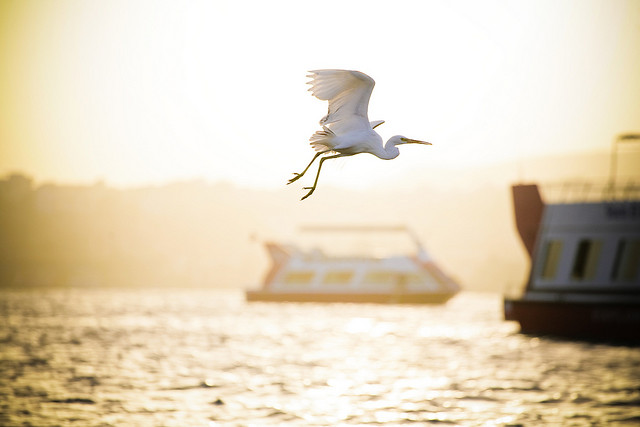What do you think the people on the boat might be experiencing? The people on the boat might be experiencing a peaceful and relaxing journey, enjoying the gentle waves and the beautiful scenery with the setting sun casting a warm glow over the water. Can you give a detailed account of what might happen next in the image? As the bird continues its flight, it will likely search for a place to land, perhaps on the quay or another spot along the waterway. Simultaneously, the boats might be coming to anchor for the evening, with their passengers preparing to disembark and enjoy the surroundings, perhaps taking a stroll along the riverside or visiting a nearby restaurant for dinner. The warm light of the setting sun will gradually fade, giving way to the cool blues of twilight, signaling the end of a tranquil day on the water. 